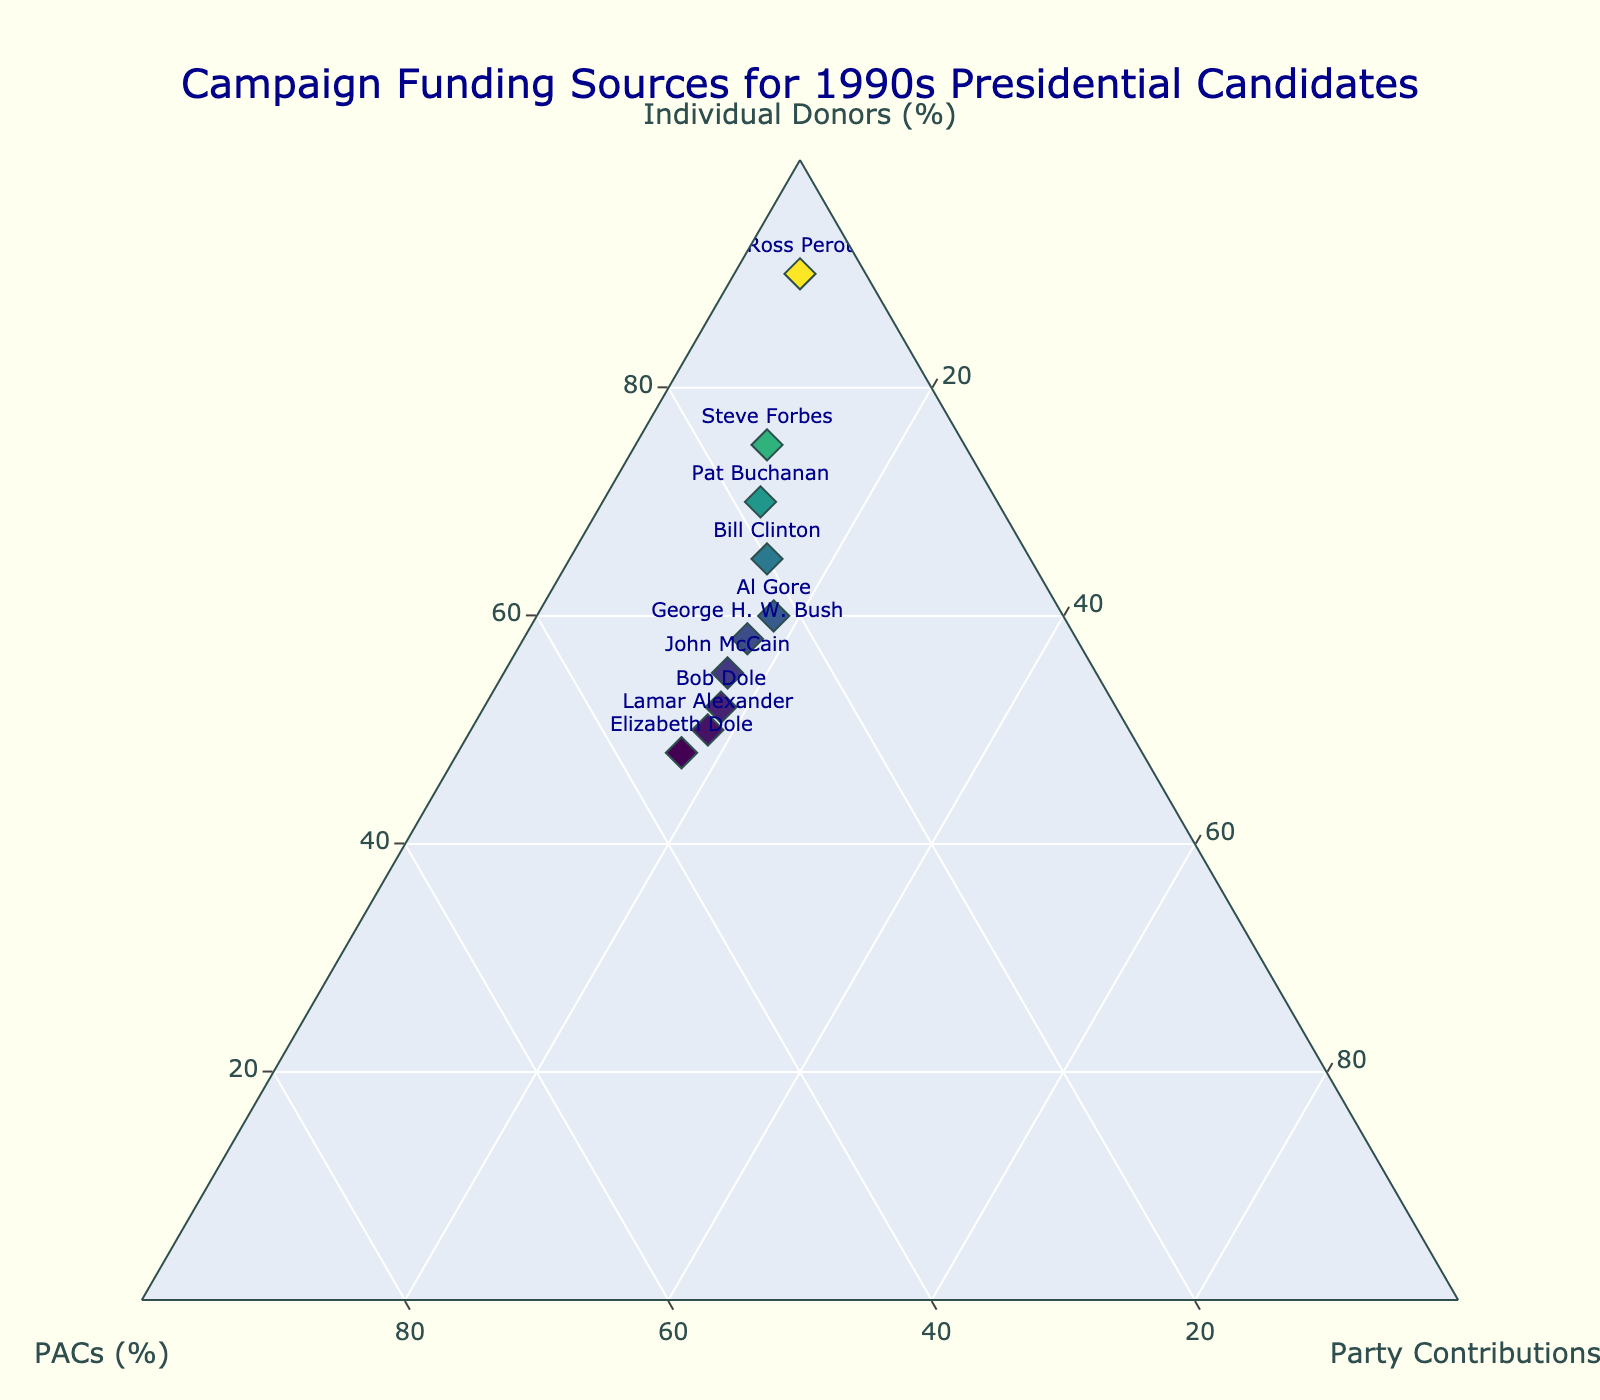What's the title of the figure? The title can be found at the top of the figure, it's usually prominent and gives a summary of what the plot represents.
Answer: Campaign Funding Sources for 1990s Presidential Candidates What are the three funding sources represented in the ternary plot? The axes titles at each corner of the ternary plot indicate the three variables being compared.
Answer: Individual Donors, PACs, Party Contributions Which candidate had the highest percentage of individual donations? By examining the points on the ternary plot, the candidate located closest to the corner labeled "Individual Donors" had the highest percentage.
Answer: Ross Perot Which candidate had a higher percentage of party contributions: Bill Clinton or George H.W. Bush? Compare the positions of Bill Clinton and George H.W. Bush relative to the "Party Contributions" axis. The closer one to this axis has the higher percentage.
Answer: George H. W. Bush Which two candidates had the highest percentage of funds from PACs? Identify points that are closest to the corner labeled "PACs" and note the corresponding candidates.
Answer: Elizabeth Dole, Lamar Alexander What's the difference in the percentage of individual donors between Steve Forbes and Pat Buchanan? Identify the positions of Steve Forbes and Pat Buchanan on the plot, refer to the individual donor axis, and calculate the difference. Steve Forbes had 75% and Pat Buchanan had 70%, the difference is 75% - 70% = 5%
Answer: 5% What is the total percentage contributed by individual donors and PACs for John McCain? Locate John McCain's position and check the percentages for individual donors and PACs, then sum these values. John McCain had 55% from individual donors and 28% from PACs, so the total is 55% + 28% = 83%
Answer: 83% Which candidate had an almost equal distribution among the three funding sources? Look for a point approximately centered within the ternary plot, indicating a nearly equal contribution from all three sources.
Answer: Al Gore Who had the least percentage of party contributions? Locate the candidate farthest from the "Party Contributions" axis. The one farthest away had the lowest percentage.
Answer: Ross Perot What is the average percentage of PACs funding for all candidates? Sum the percentages of PACs for each candidate, then divide by the number of candidates. (20+25+30+5+22+28+15+18+32+35) / 10 = 23%
Answer: 23% 